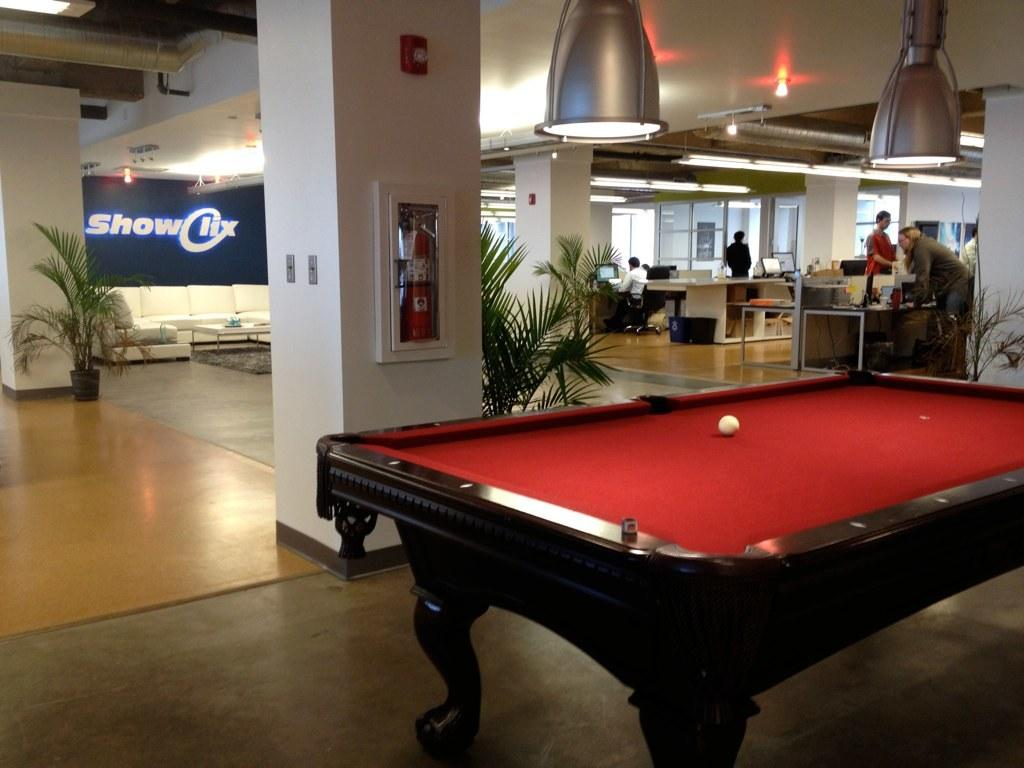What is the main piece of furniture in the image? There is a table in the image. What object is on the table? There is a ball on the table. What type of vegetation is visible in the image? There are plants visible in the image. What type of illumination is present in the image? There are lights in the image. What can be seen in the background of the image? There are people, tables, and monitors in the background of the image. Can you hear the fowl crying in the image? There is no fowl or crying sound present in the image. What type of ocean can be seen in the image? There is no ocean visible in the image. 